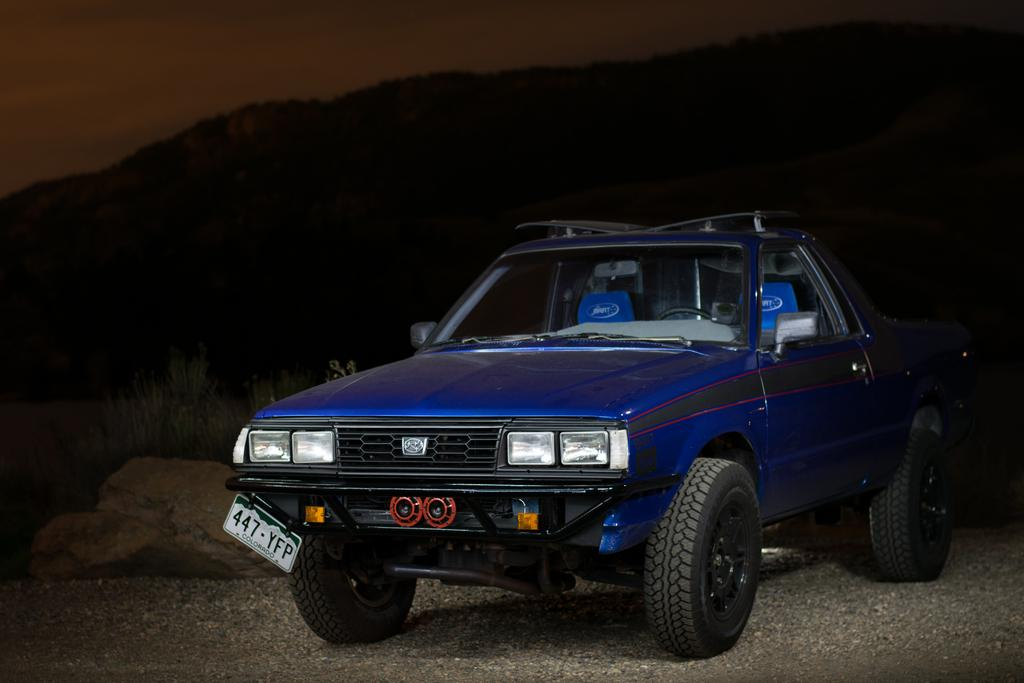What is the main subject in the center of the image? There is a car in the center of the image. What color is the car? The car is blue in color. What can be seen on the left side of the image? There are rocks on the left side of the image. Can you see a cat playing with a bone near the car in the image? No, there is no cat or bone present in the image. 